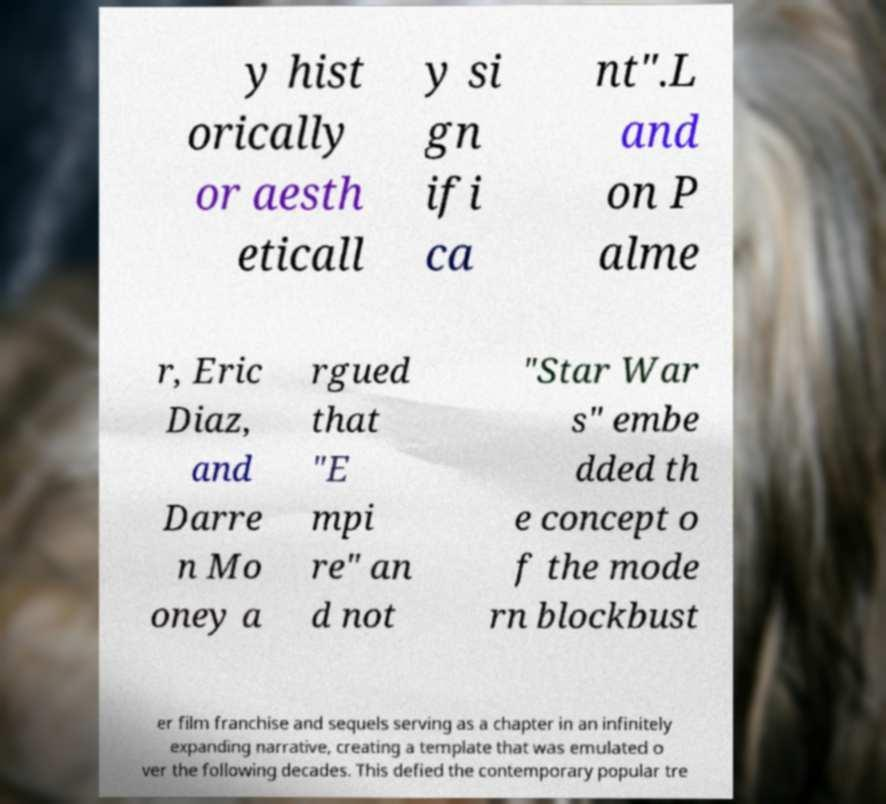Please read and relay the text visible in this image. What does it say? y hist orically or aesth eticall y si gn ifi ca nt".L and on P alme r, Eric Diaz, and Darre n Mo oney a rgued that "E mpi re" an d not "Star War s" embe dded th e concept o f the mode rn blockbust er film franchise and sequels serving as a chapter in an infinitely expanding narrative, creating a template that was emulated o ver the following decades. This defied the contemporary popular tre 